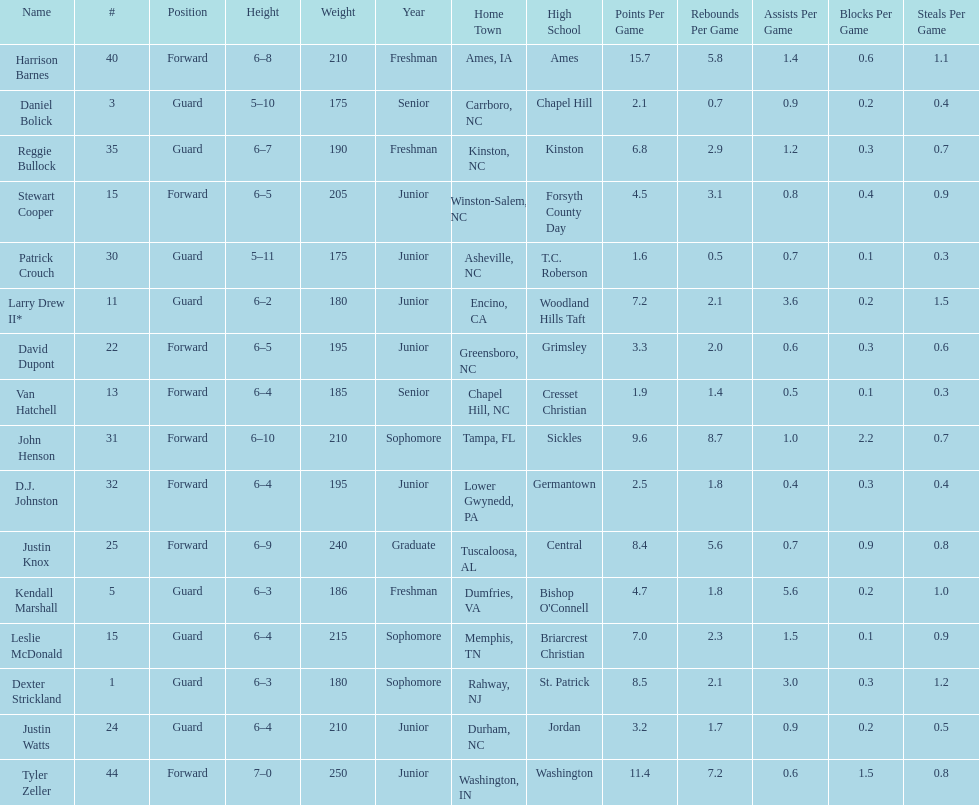Tallest player on the team Tyler Zeller. 